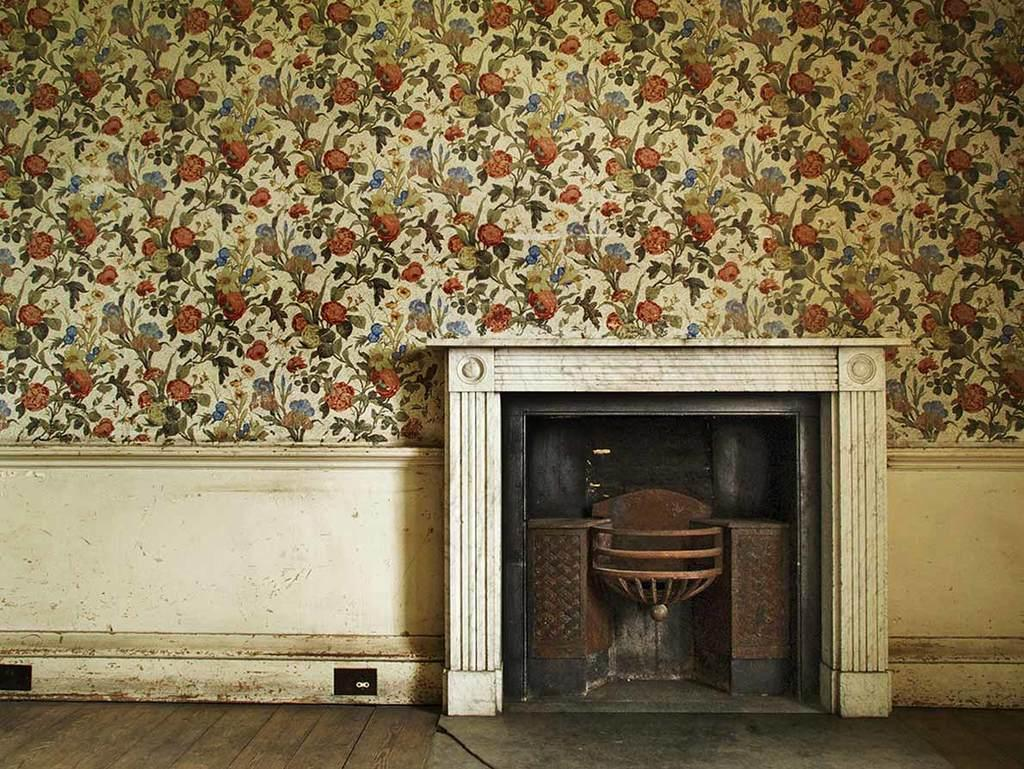What is on the wall in the image? There is a wall with designs in the image. What is on the wall besides the designs? There is a box with pillars on the wall. What features are present on the box? There are stands on the box. Is there anything else on the box besides the stands? Yes, there is an unspecified "other thing" on the box. What type of credit can be seen on the box in the image? There is no credit visible on the box in the image. What is the company that manufactures the string on the box in the image? There is no string or company mentioned in the image. 